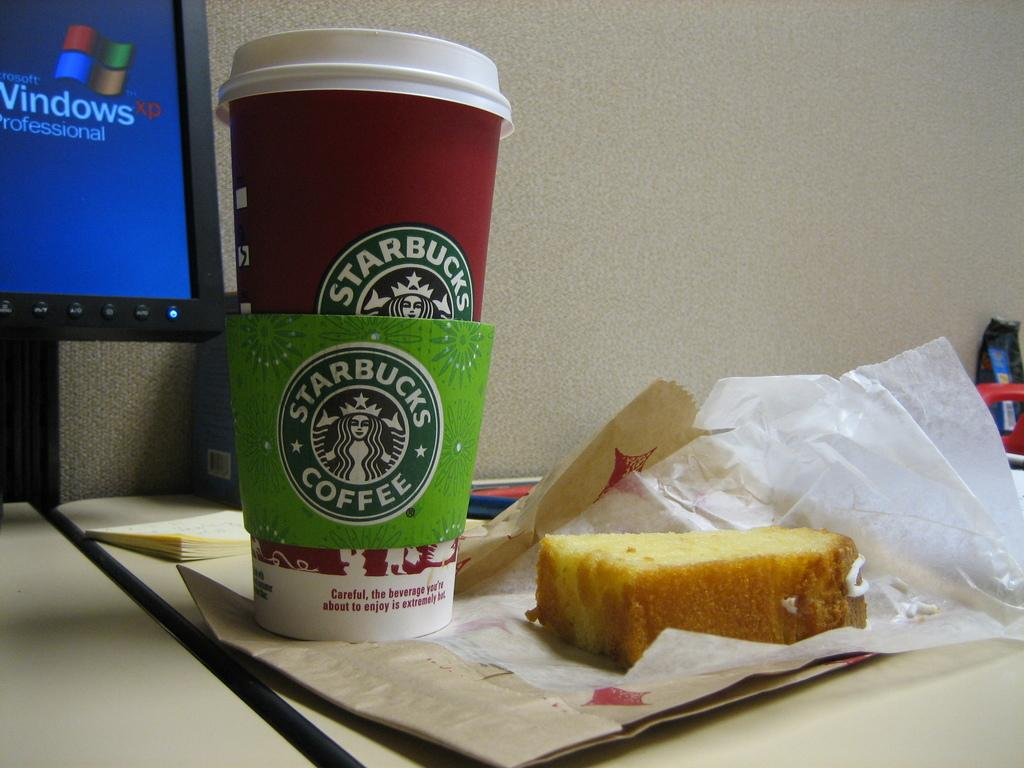What type of food is visible in the image? The food in the image is brown in color. How is the food presented in the image? The food is on a paper. What other objects can be seen in the image? There are glasses and a system on the table. What is the color of the background in the image? The background of the image is cream in color. What type of rod is used to stir the thoughts in the image? There is no rod or stirring of thoughts present in the image. 